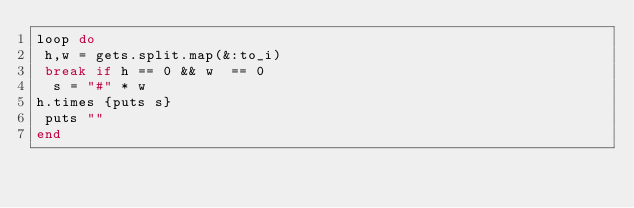Convert code to text. <code><loc_0><loc_0><loc_500><loc_500><_Ruby_>loop do
 h,w = gets.split.map(&:to_i)
 break if h == 0 && w  == 0
  s = "#" * w
h.times {puts s}
 puts ""
end
</code> 